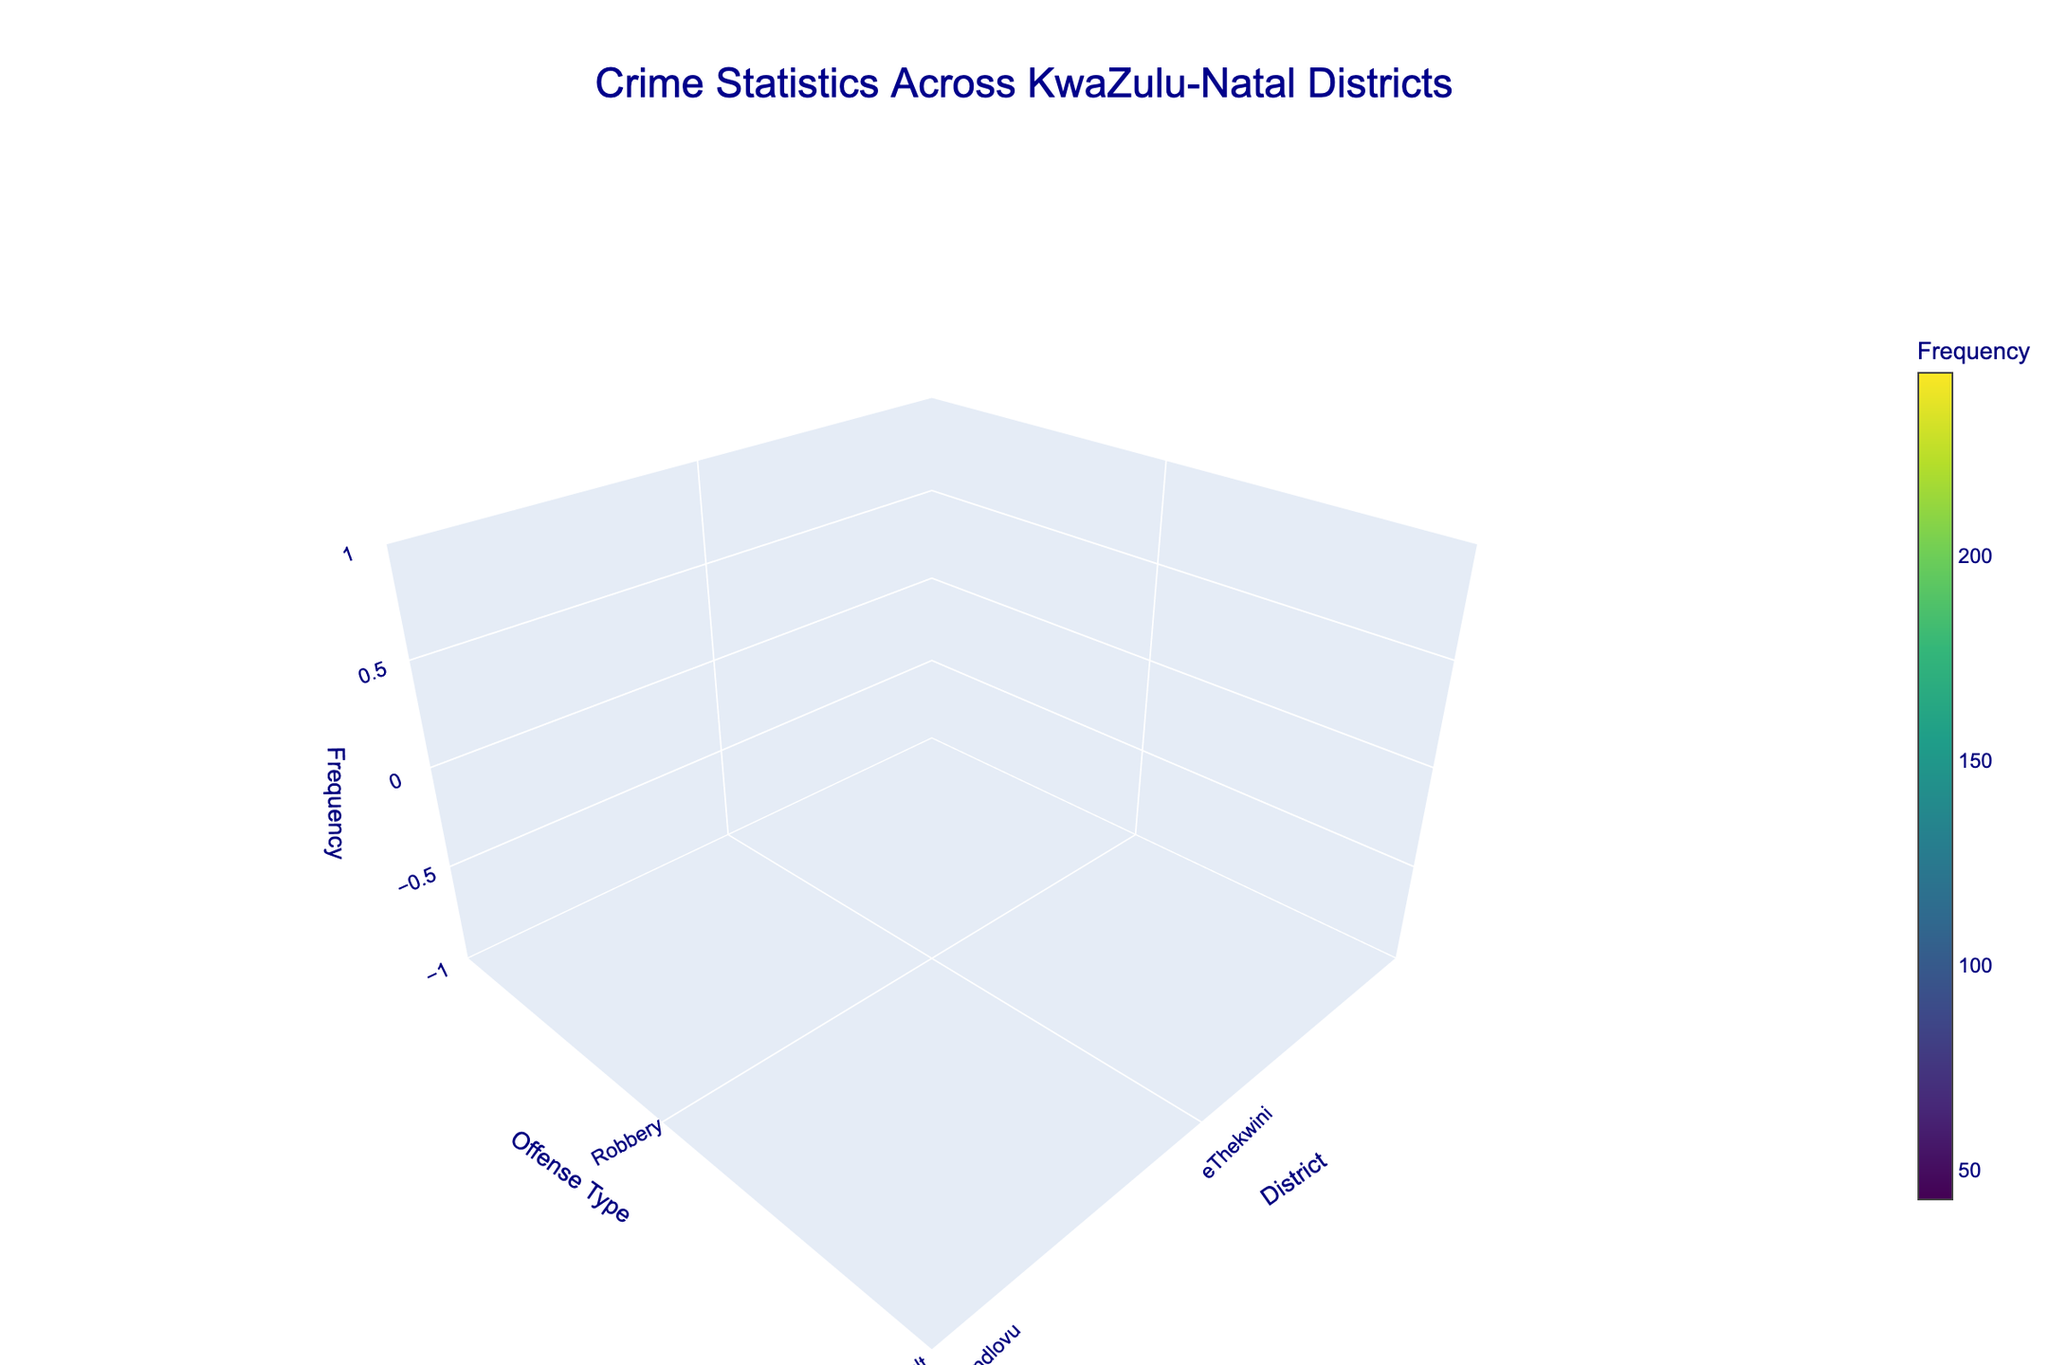What is the title of the plot? The title of the plot is typically displayed at the top of the figure. It gives a summary of what the plot is about. In this case, we look at the top and find the title.
Answer: Crime Statistics Across KwaZulu-Natal Districts Which district has the highest frequency of robbery? To answer this, locate "Robbery" on the y-axis, then look for the highest point on the z-axis within this category. Trace this back to the x-axis to identify the district.
Answer: eThekwini What is the sum of frequencies for Theft and Assault? First determine the frequency for each: find "Theft" on the y-axis (201), then find "Assault" (178). Add these two numbers together: 201 + 178.
Answer: 379 Which district has the lowest frequency of murder, and what is that frequency? Locate the "Murder" row on the y-axis, identify the lowest point in this row on the z-axis, and trace it back to the district on the x-axis. The frequency value and the corresponding district will be the answer.
Answer: Uthukela, 67 How do the occurrences of drug-related offenses in iLembe compare to domestic violence in Amajuba? Locate "Drug-related" on the y-axis and identify its peak on the z-axis for the iLembe district. Then do the same for "Domestic Violence" in Amajuba. Compare their z-values (frequency). iLembe's "Drug-related" frequency is 112, and Amajuba's "Domestic Violence" frequency is 156.
Answer: Domestic violence in Amajuba is higher On which offense type is the KwaZulu-Natal as a whole most heavily impacted, based on frequency? Identify which offense type has the highest peak on the z-axis across all districts by looking along the y-axis and comparing z-values in each category.
Answer: Robbery Which district has the highest number of unique offense types, and how many are there? Count the number of distinct offense types (points along the y-axis) for each district. Identify the district with the most unique offense types.
Answer: eThekwini, 1 Which district has the second-highest frequency of offenses overall? Sum the frequencies of all offenses for each district and then rank them. The district with the second-highest total is the answer. Check each district and sum their values to find the totals, then identify the second highest.
Answer: Ugu Between Zululand and Harry Gwala, which district experiences higher incidents of carjacking and by how much? Locate the "Carjacking" category on the y-axis and compare the z-values for both Zululand and Harry Gwala. Zululand's value is 89, while Harry Gwala does not have carjacking incidents listed. Hence, the difference is 89.
Answer: Zululand, 89 Calculate the average frequency of fraud offenses across all districts. Identify all the frequencies for "Fraud" on the y-axis. As uMkhanyakude is the only district with fraud offenses listed (78), the average is 78 (since it's an average of one value).
Answer: 78 